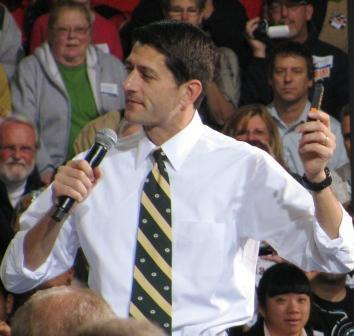Give a concise rundown of the primary subject in the image and any unique characteristics they possess. A man donning a white shirt, striped tie, watch, and ring is captured holding a wireless microphone. Enumerate the key elements concerning the principal figure in the photograph. Man with dark hair, white shirt, striped tie, ring, watch, holding a cordless microphone and surrounded by people. Quickly describe the main character in the image and any notable features or actions they exhibit. A dark-haired gentleman wearing a white shirt, striped tie, watch, and ring can be seen holding a cordless microphone. Provide a quick overview of the focal point of the image, highlighting any distinctive aspects. A stylish man in a white shirt, striped tie, watch, and ring holds a cordless microphone, with onlookers in the background. Present a snapshot summary of the central figure in the image and any noteworthy attributes they display. A well-dressed man, sporting a white shirt, striped tie, watch, and ring, takes center-stage holding a cordless microphone. Identify the prominent individual in the image and describe their overall appearance. The main person in the image is a man with dark hair, wearing a white shirt, striped tie, watch, and ring, and holding a microphone. Mention the most striking individual in the frame and their actions or features. A dark-haired man wearing a white shirt, striped tie, a ring, and a watch is holding a cordless microphone. Outline the main individual within the image and any distinguishing features or actions they are undertaking. A man clad in a white shirt, striped tie, and adorned with a watch and ring is engaged in using a wireless microphone. Summarize the most noticeable components concerning the central character in the picture. Man in white shirt, striped tie, watch, and ring, holding a wireless microphone with people sitting behind him. Provide a brief description of the primary person in the image and any accessories they are using. A man wearing a white shirt is holding a cordless microphone, has a striped tie, and is wearing a watch and a ring. 